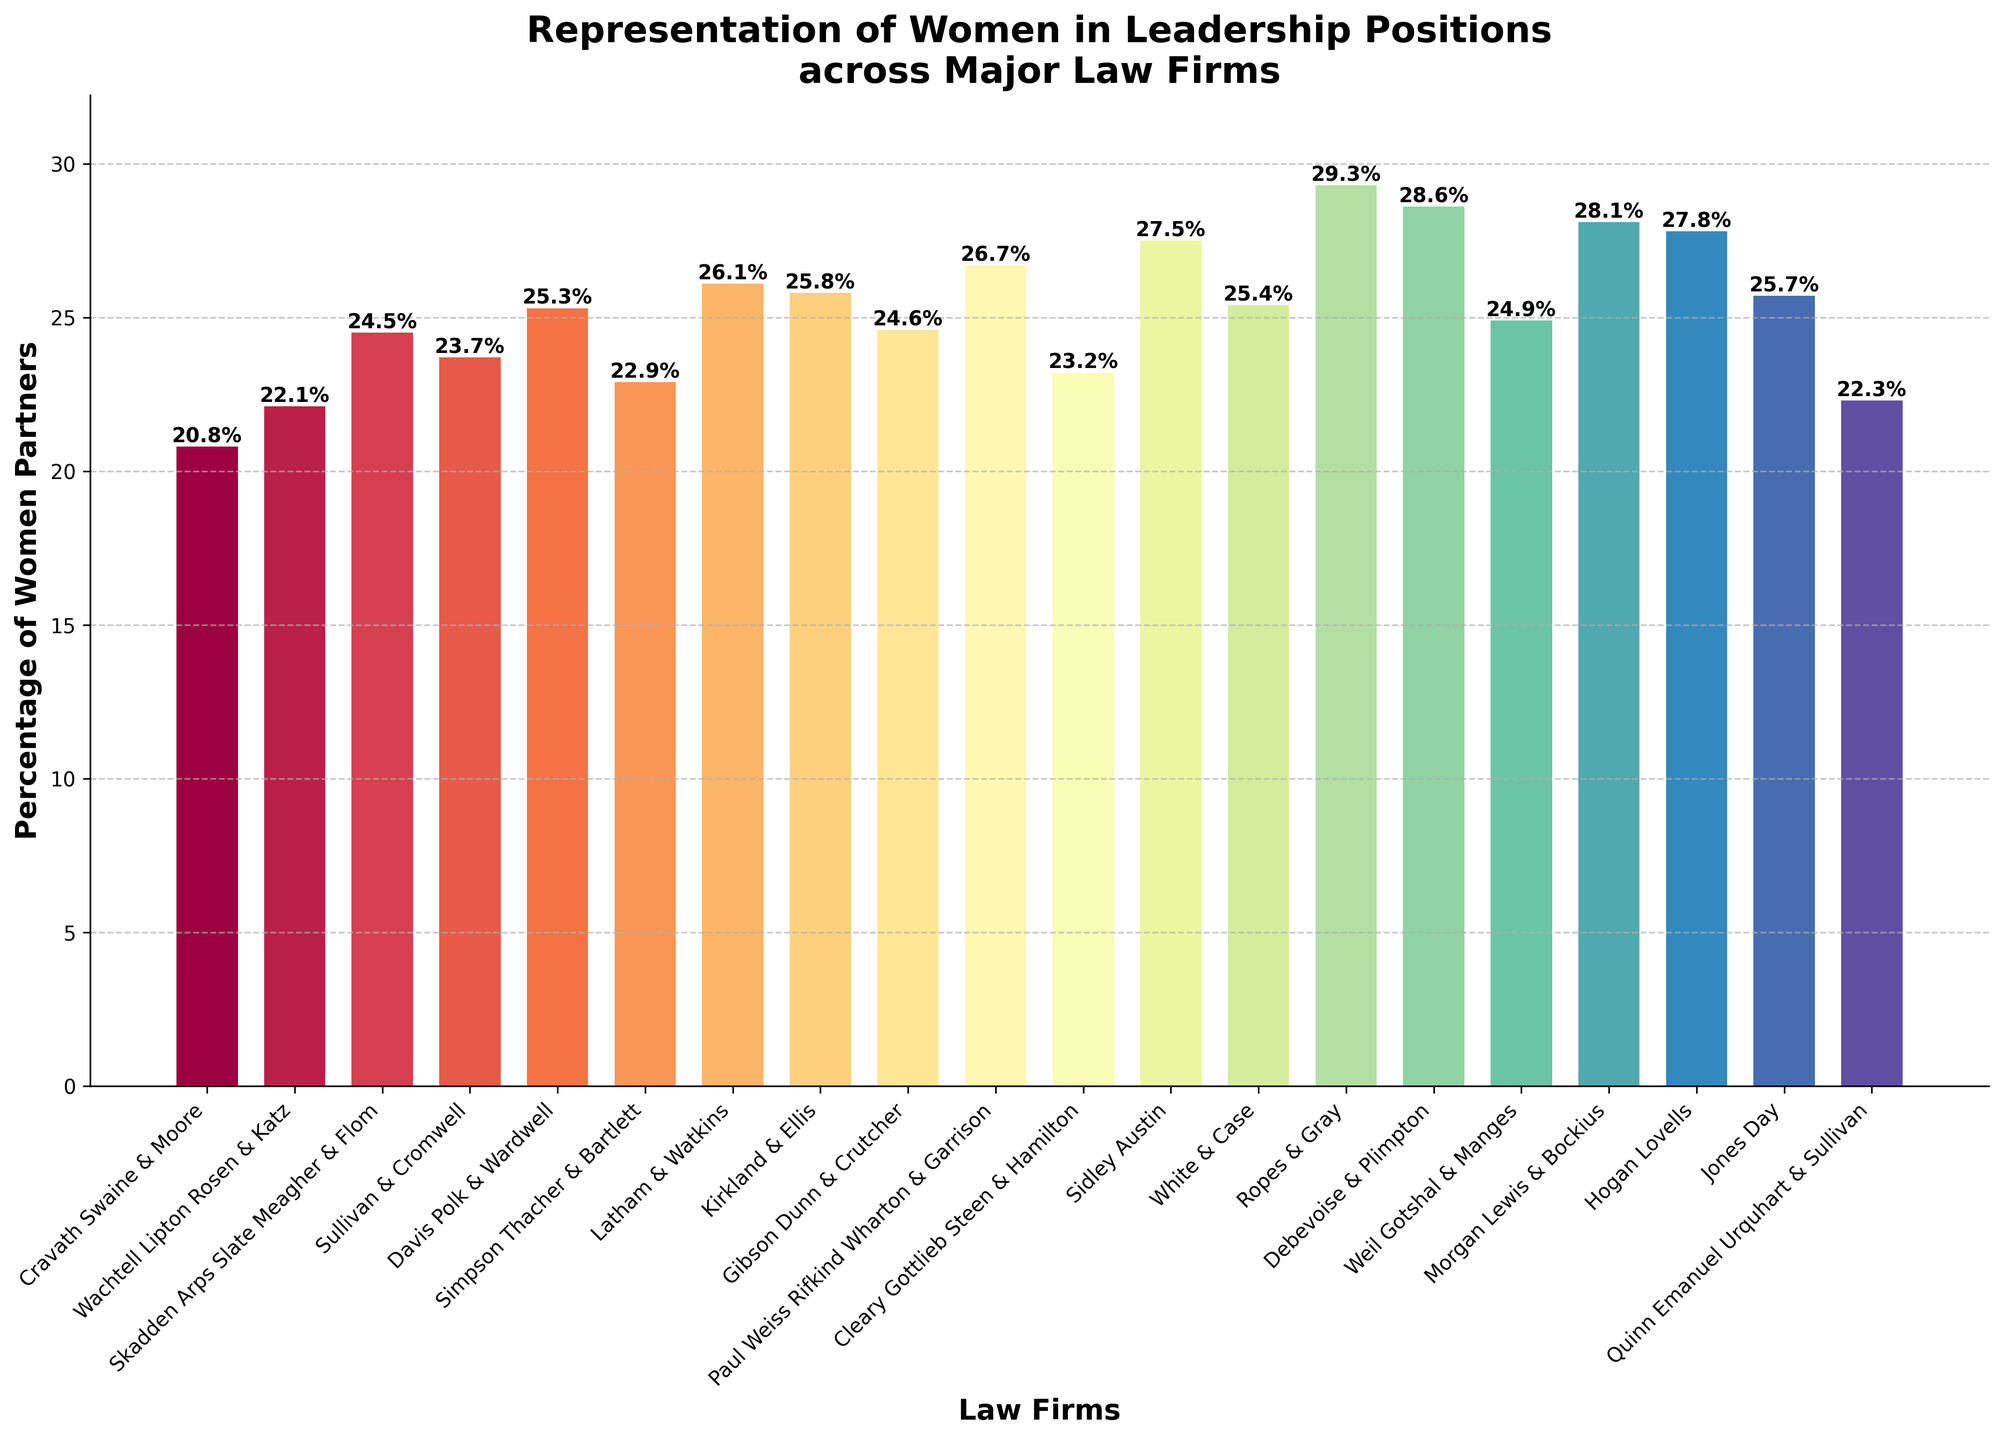Which law firm has the highest percentage of women partners? Look for the tallest bar in the bar chart.
Answer: Ropes & Gray Which two firms have the closest percentage of women partners? Observe bars that are adjacent in height to each other.
Answer: White & Case and Jones Day What is the range of percentages for women partners across all firms? Subtract the smallest percentage (Cravath Swaine & Moore, 20.8%) from the largest percentage (Ropes & Gray, 29.3%).
Answer: 8.5% How many firms have a percentage of women partners of 25% or more? Count the number of bars with height above or equal to 25%.
Answer: 11 What is the difference in the percentage of women partners between the firm with the highest and lowest representation? Subtract the percentage of Cravath Swaine & Moore (20.8%) from Ropes & Gray (29.3%).
Answer: 8.5% How does Sidley Austin's representation of women partners compare to Debevoise & Plimpton? Compare the heights of the bars for Sidley Austin (27.5%) and Debevoise & Plimpton (28.6%).
Answer: Debevoise & Plimpton has a higher percentage What is the average percentage of women partners across all the firms shown? Add all the percentages and divide by the total number of firms (19).
Answer: 24.9% Which firm has a percentage of women partners just below Debevoise & Plimpton? Look for the bar just shorter than Debevoise & Plimpton (28.6%).
Answer: Ropes & Gray What percentage of women partners does Cravath Swaine & Moore have? Refer to the specific bar for Cravath Swaine & Moore.
Answer: 20.8% How much higher is the percentage of women partners at Paul Weiss compared to Sullivan & Cromwell? Subtract Sullivan & Cromwell's percentage (23.7%) from Paul Weiss's (26.7%).
Answer: 3% 